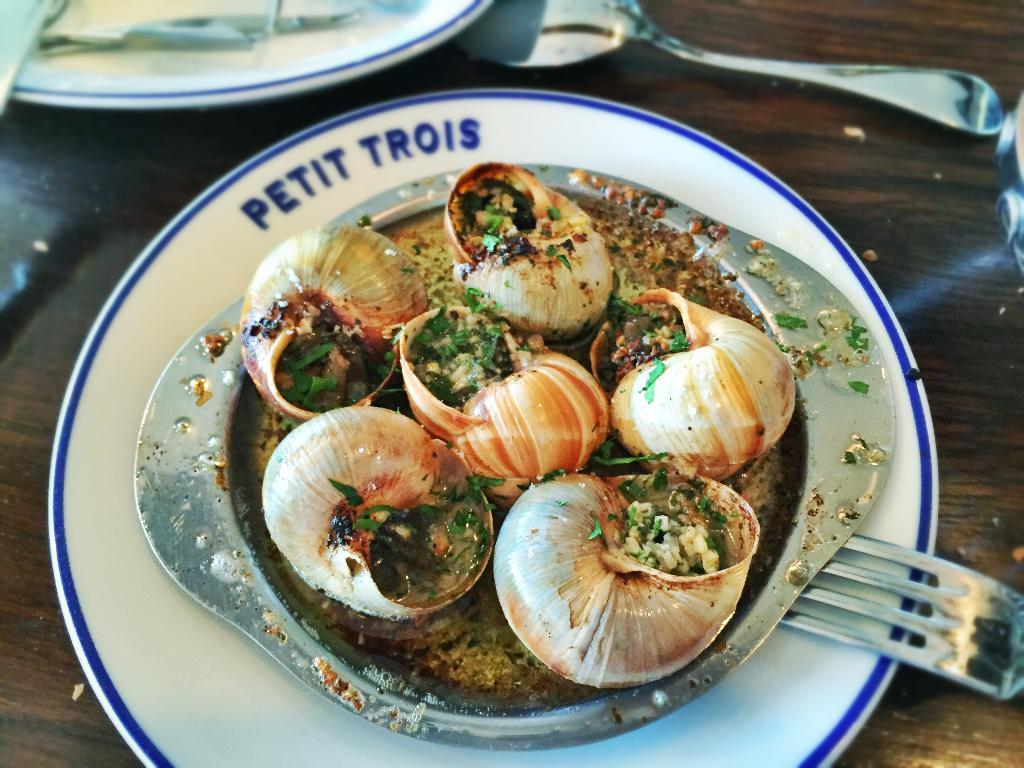What is the color of the surface in the image? The surface in the image is brown colored. What utensils can be seen on the surface? Spoons and forks are visible on the surface. How many plates are present on the surface? There are two plates on the surface. What is on one of the plates? There is a bowl with shells on one of the plates. What is on the shells in the bowl? There are herbs on the shells in the bowl. What type of pizzas are being served to the army in the image? There are no pizzas or army members present in the image. What is the relation between the people eating the food in the image? There is no information about the people eating the food or their relation in the image. 